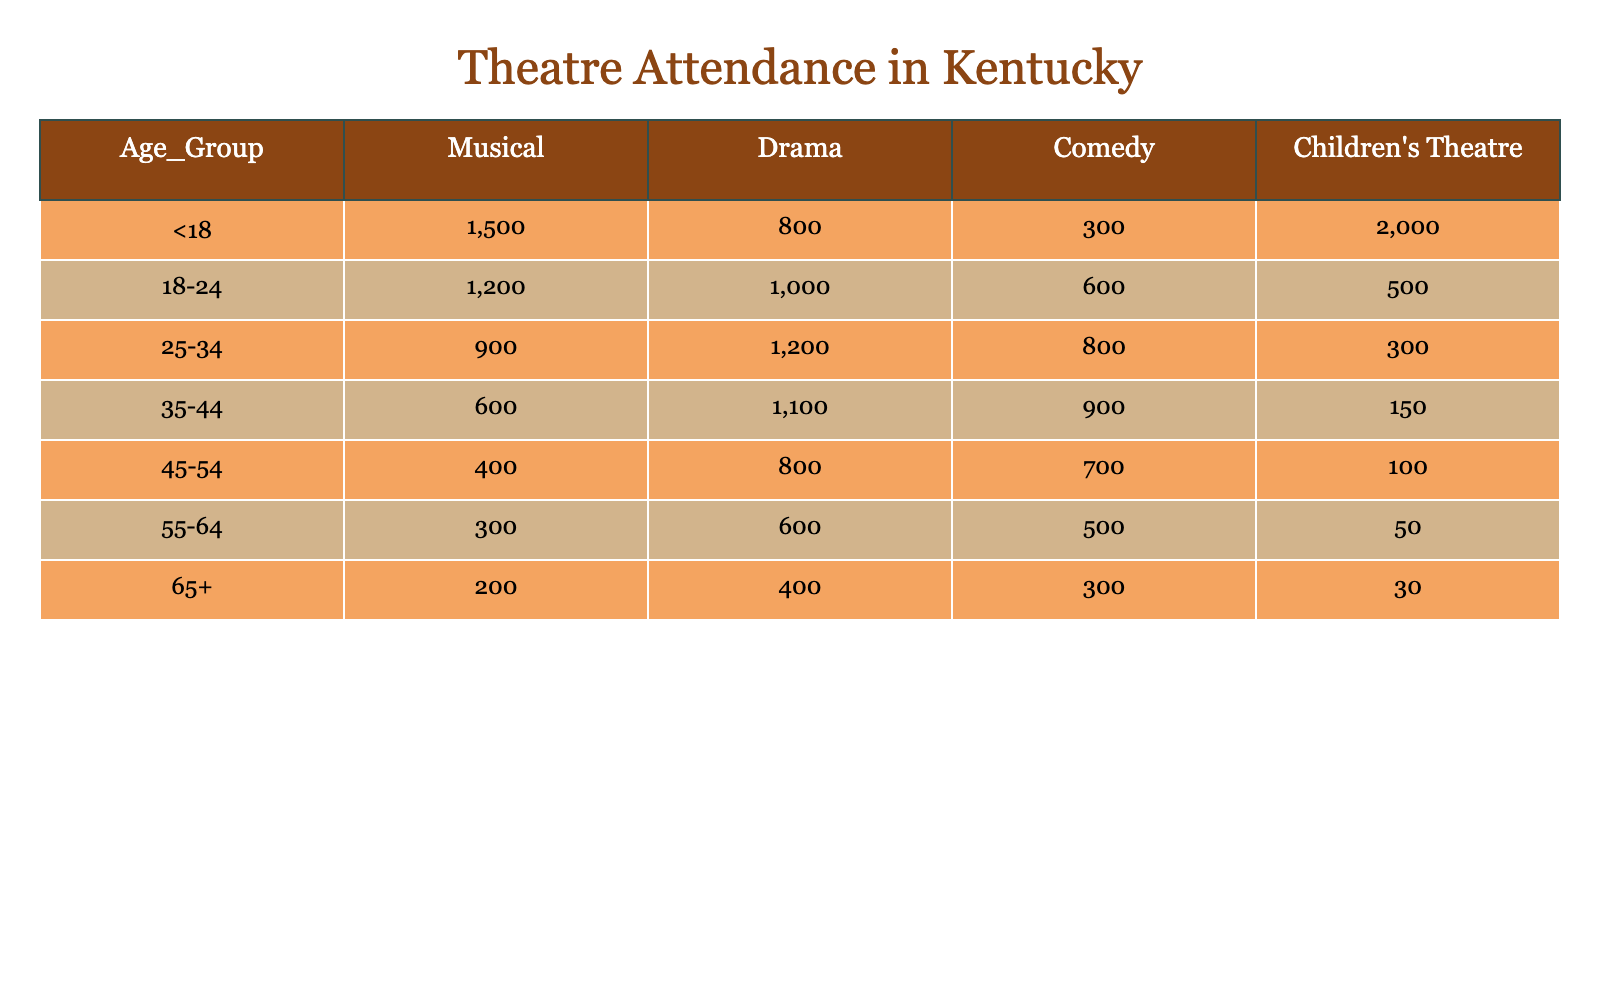What is the total attendance for Children's Theatre among ages 35-44? Looking at the Children's Theatre column, the attendance for the age group 35-44 is 150. This value can be found directly in the table.
Answer: 150 Which performance type had the highest attendance for the age group <18? For the age group <18, the attendance figures are: Musical 1500, Drama 800, Comedy 300, and Children's Theatre 2000. The highest value among these is for Children's Theatre at 2000.
Answer: Children's Theatre What is the average attendance for Drama across all age groups? To find the average attendance for Drama, we first sum the attendance figures: 800 + 1000 + 1200 + 1100 + 800 + 600 + 400 = 5100. There are 7 age groups, so we divide 5100 by 7, which equals approximately 728.57, rounded to 729.
Answer: 729 Is there more attendance for Comedy or Drama in the age group 45-54? The attendance figures for the age group 45-54 are: Drama 800 and Comedy 700. Since 800 (Drama) is greater than 700 (Comedy), the statement is true.
Answer: Yes What is the combined total attendance for the 25-34 age group across all performance types? For the age group 25-34, the attendance figures are: Musical 900, Drama 1200, Comedy 800, and Children's Theatre 300. Summing these gives 900 + 1200 + 800 + 300 = 3200. Therefore, the combined total is 3200.
Answer: 3200 Which age group had the lowest attendance for Musicals? Reviewing the Musical column, the attendance figures are: 1500 for <18, 1200 for 18-24, 900 for 25-34, 600 for 35-44, 400 for 45-54, 300 for 55-64, and 200 for 65+. The lowest value is 200 for the age group 65+.
Answer: 65+ What is the difference in attendance between Comedy and Musical for the age group 18-24? The attendance for the age group 18-24 is 1200 for Musical and 600 for Comedy. The difference is computed as 1200 - 600 = 600.
Answer: 600 Which performance type had the highest total attendance across all age groups? Summing the attendance for each performance type across all age groups gives the following totals: Musical 1500 + 1200 + 900 + 600 + 400 + 300 + 200 = 4100, Drama 800 + 1000 + 1200 + 1100 + 800 + 600 + 400 = 5100, Comedy 300 + 600 + 800 + 900 + 700 + 500 + 300 = 4100, and Children's Theatre 2000 + 500 + 300 + 150 + 100 + 50 + 30 = 3130. The highest total is for Drama at 5100.
Answer: Drama Is the total attendance for the age group 55-64 greater than the total for 65+? For the age group 55-64, the attendances are: Musical 300, Drama 600, Comedy 500, and Children's Theatre 50, which sums to 1450. For 65+, the values are 200, 400, 300, and 30, totaling 930. Since 1450 > 930, the statement is true.
Answer: Yes 